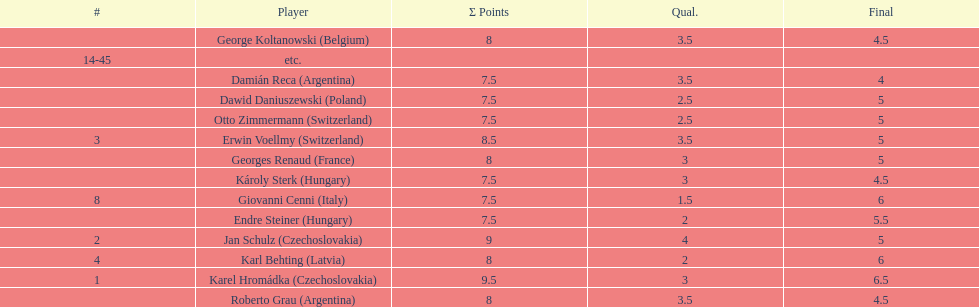Which player had the largest number of &#931; points? Karel Hromádka. 